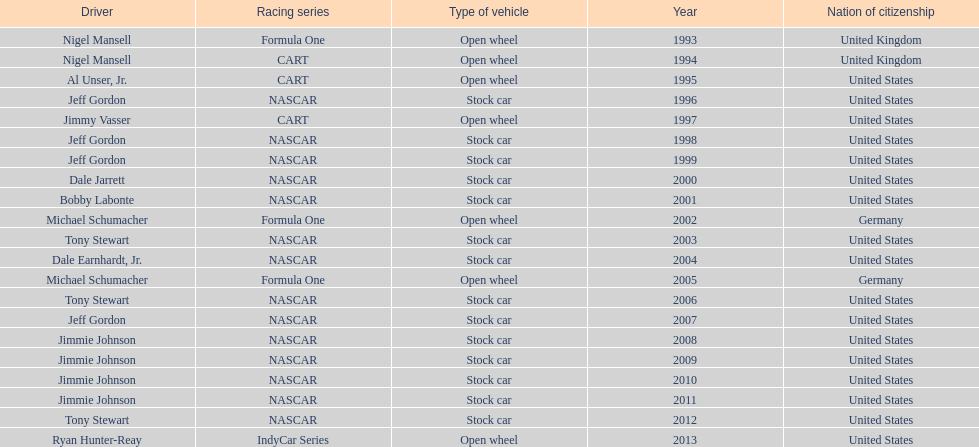Besides nascar, what other racing series have espy-winning drivers come from? Formula One, CART, IndyCar Series. 